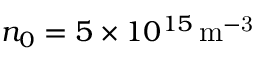<formula> <loc_0><loc_0><loc_500><loc_500>n _ { 0 } = 5 \times 1 0 ^ { 1 5 } \, m ^ { - 3 }</formula> 